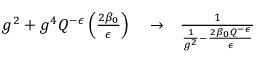Convert formula to latex. <formula><loc_0><loc_0><loc_500><loc_500>\begin{array} { r l r } { g ^ { 2 } + g ^ { 4 } Q ^ { - \epsilon } \left ( \frac { 2 \beta _ { 0 } } { \epsilon } \right ) } & \to } & { { \frac { 1 } { { \frac { 1 } { g ^ { 2 } } } - { \frac { 2 \beta _ { 0 } Q ^ { - \epsilon } } { \epsilon } } } } } \end{array}</formula> 